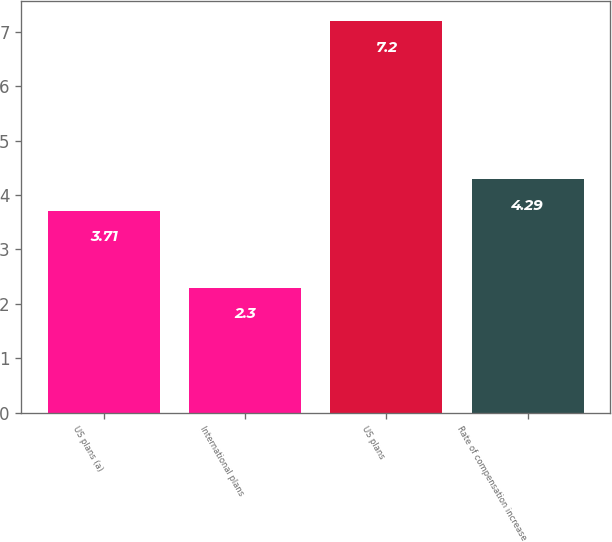<chart> <loc_0><loc_0><loc_500><loc_500><bar_chart><fcel>US plans (a)<fcel>International plans<fcel>US plans<fcel>Rate of compensation increase<nl><fcel>3.71<fcel>2.3<fcel>7.2<fcel>4.29<nl></chart> 